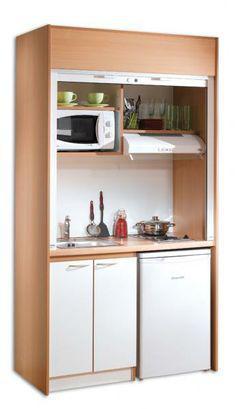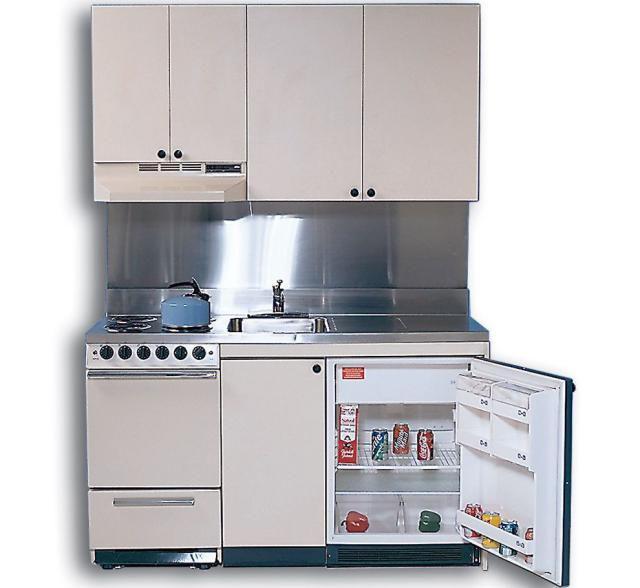The first image is the image on the left, the second image is the image on the right. Analyze the images presented: Is the assertion "In at least one image there is a small fridge that door is open to the right." valid? Answer yes or no. Yes. The first image is the image on the left, the second image is the image on the right. For the images shown, is this caption "Both refrigerators have a side compartment." true? Answer yes or no. No. 